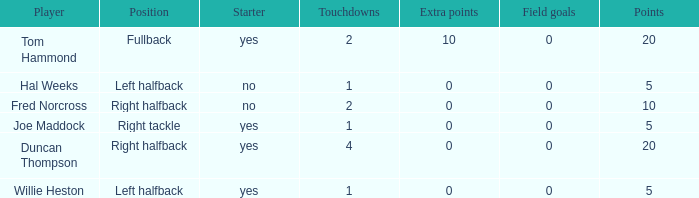How many field goals did duncan thompson have? 0.0. 